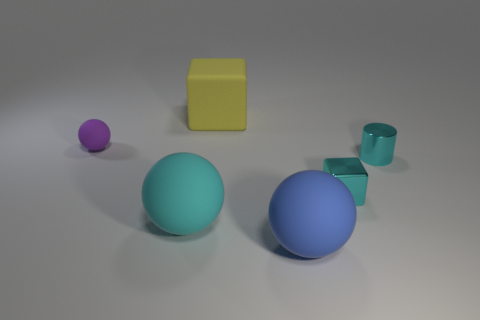Add 2 big yellow matte objects. How many objects exist? 8 Subtract all large cyan spheres. How many spheres are left? 2 Subtract all cubes. How many objects are left? 4 Subtract 1 blocks. How many blocks are left? 1 Subtract all blue blocks. Subtract all cyan cylinders. How many blocks are left? 2 Subtract all gray cylinders. How many cyan spheres are left? 1 Subtract all yellow rubber things. Subtract all gray shiny blocks. How many objects are left? 5 Add 6 big matte balls. How many big matte balls are left? 8 Add 4 yellow metallic objects. How many yellow metallic objects exist? 4 Subtract all blue spheres. How many spheres are left? 2 